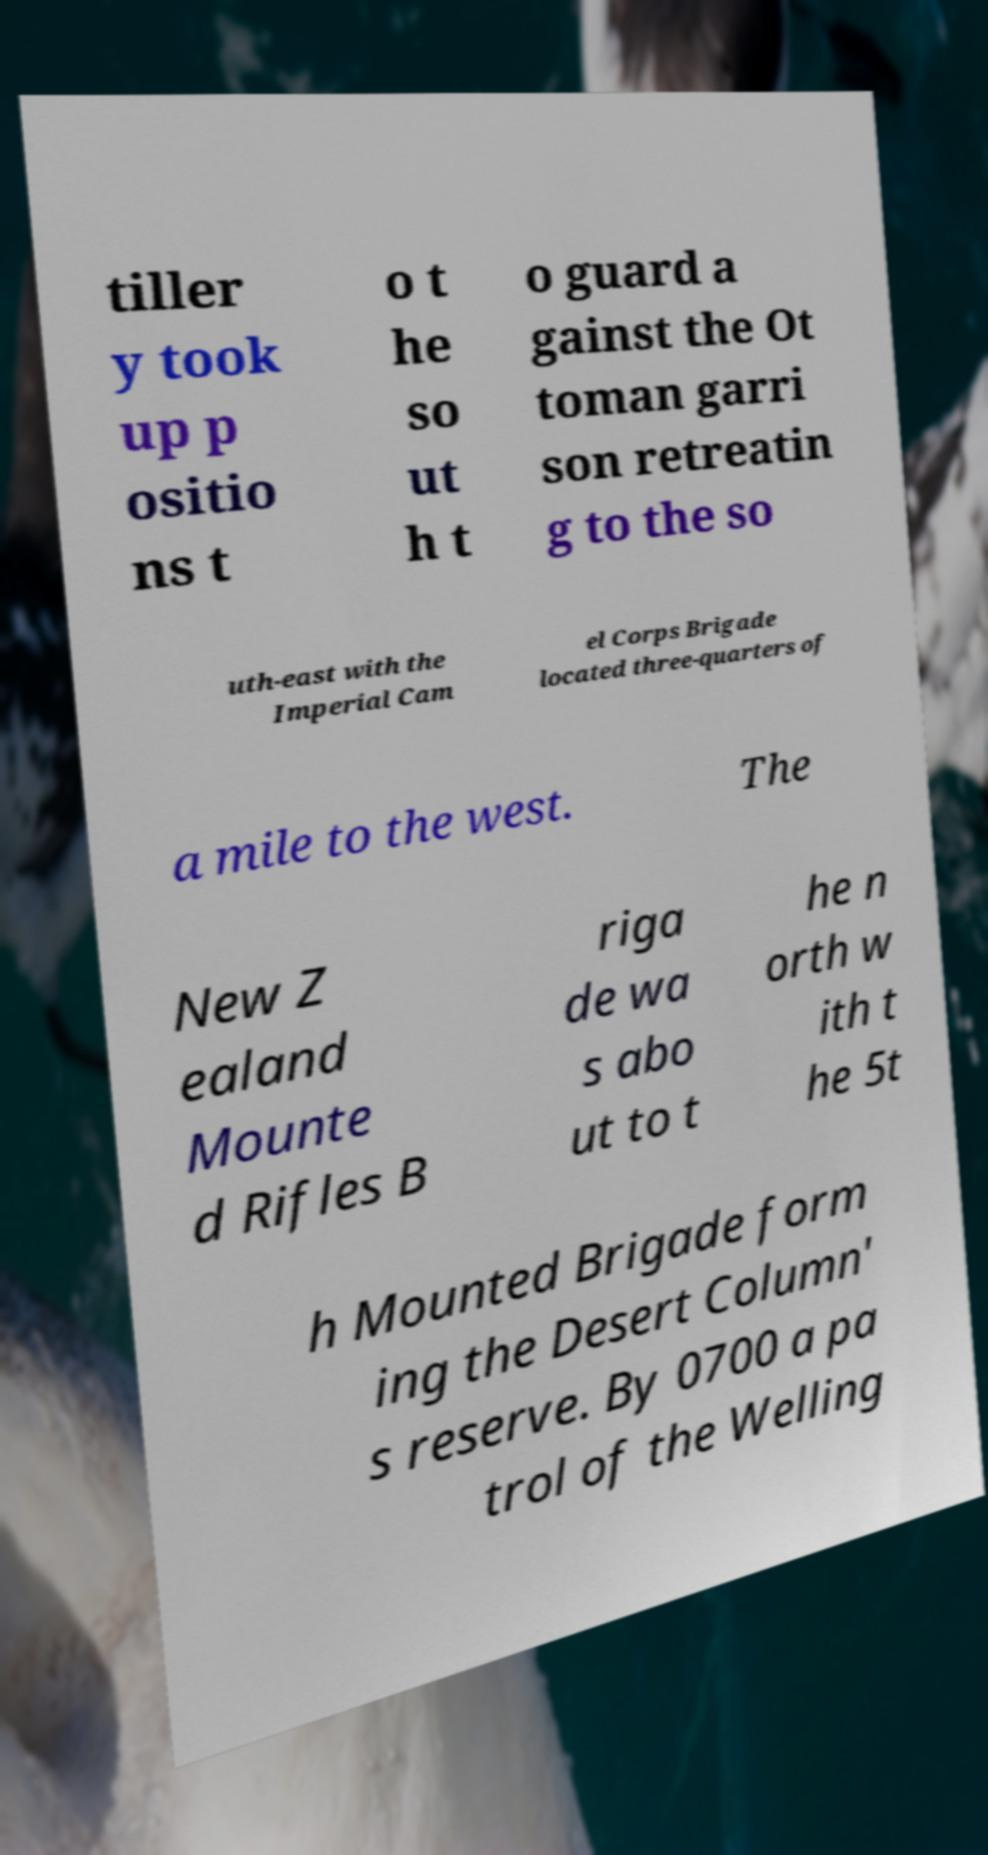Could you assist in decoding the text presented in this image and type it out clearly? tiller y took up p ositio ns t o t he so ut h t o guard a gainst the Ot toman garri son retreatin g to the so uth-east with the Imperial Cam el Corps Brigade located three-quarters of a mile to the west. The New Z ealand Mounte d Rifles B riga de wa s abo ut to t he n orth w ith t he 5t h Mounted Brigade form ing the Desert Column' s reserve. By 0700 a pa trol of the Welling 